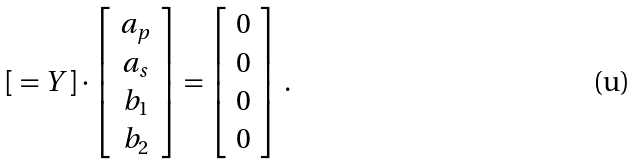<formula> <loc_0><loc_0><loc_500><loc_500>[ \ = Y ] \cdot \left [ \begin{array} { c } a _ { p } \\ a _ { s } \\ b _ { 1 } \\ b _ { 2 } \end{array} \right ] = \left [ \begin{array} { c } 0 \\ 0 \\ 0 \\ 0 \end{array} \right ] \, .</formula> 